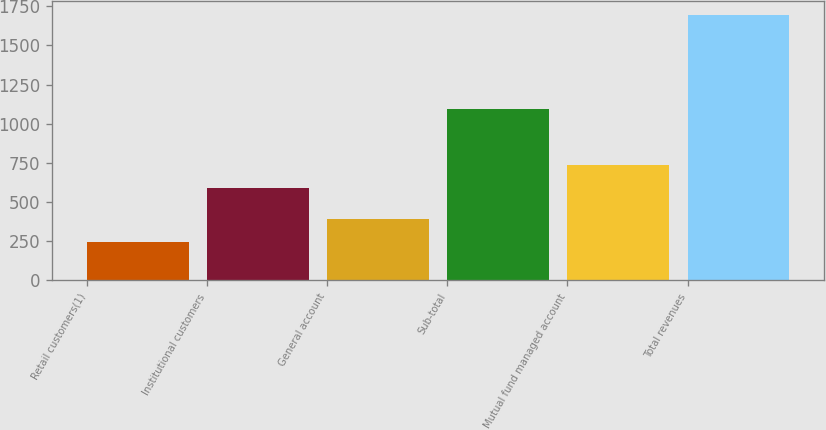<chart> <loc_0><loc_0><loc_500><loc_500><bar_chart><fcel>Retail customers(1)<fcel>Institutional customers<fcel>General account<fcel>Sub-total<fcel>Mutual fund managed account<fcel>Total revenues<nl><fcel>244<fcel>593<fcel>389.2<fcel>1094<fcel>738.2<fcel>1696<nl></chart> 